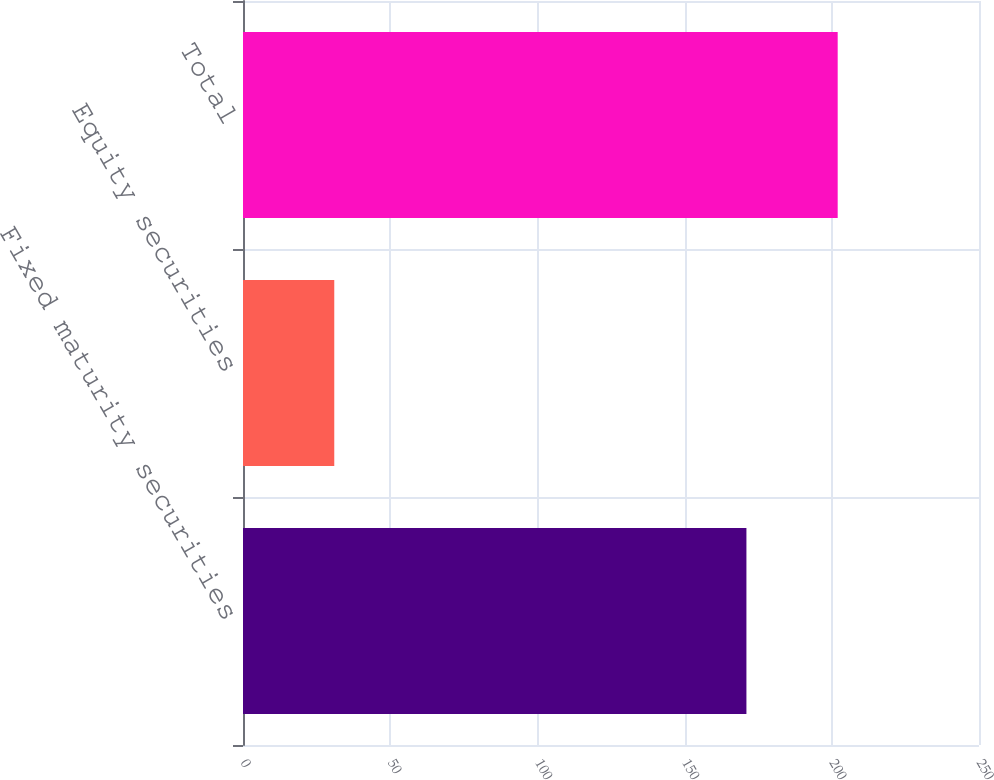Convert chart. <chart><loc_0><loc_0><loc_500><loc_500><bar_chart><fcel>Fixed maturity securities<fcel>Equity securities<fcel>Total<nl><fcel>171<fcel>31<fcel>202<nl></chart> 